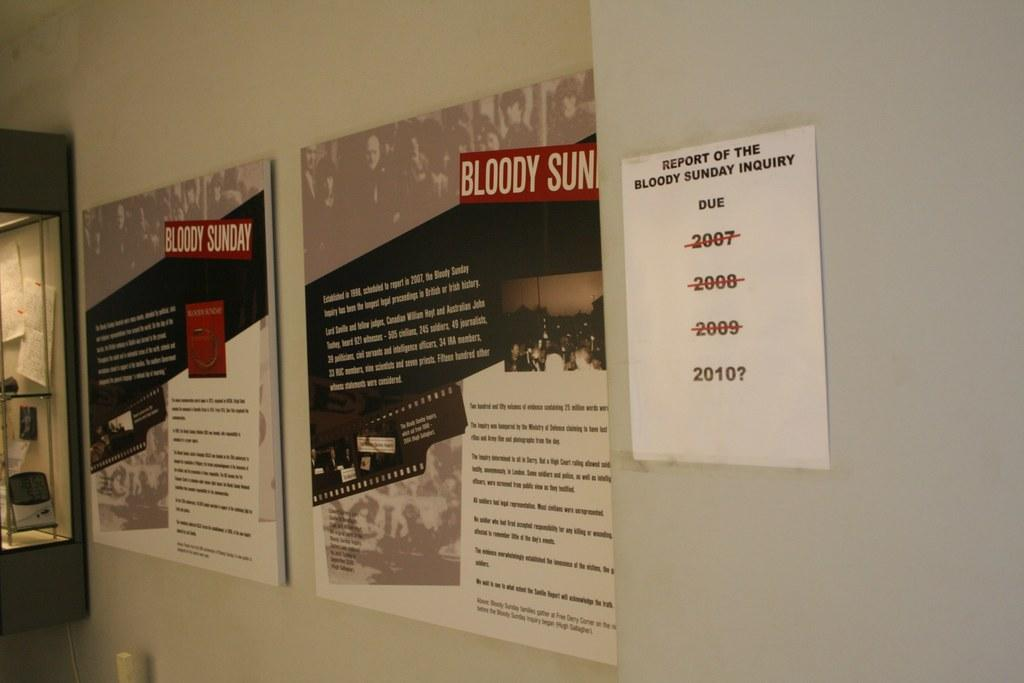<image>
Create a compact narrative representing the image presented. White paper posted on a wall with the years crossed out except 2010. 